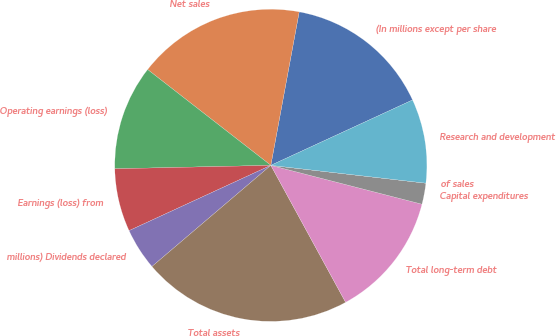Convert chart. <chart><loc_0><loc_0><loc_500><loc_500><pie_chart><fcel>(In millions except per share<fcel>Net sales<fcel>Operating earnings (loss)<fcel>Earnings (loss) from<fcel>millions) Dividends declared<fcel>Total assets<fcel>Total long-term debt<fcel>Capital expenditures<fcel>of sales<fcel>Research and development<nl><fcel>15.21%<fcel>17.39%<fcel>10.87%<fcel>6.52%<fcel>4.35%<fcel>21.73%<fcel>13.04%<fcel>2.18%<fcel>0.0%<fcel>8.7%<nl></chart> 